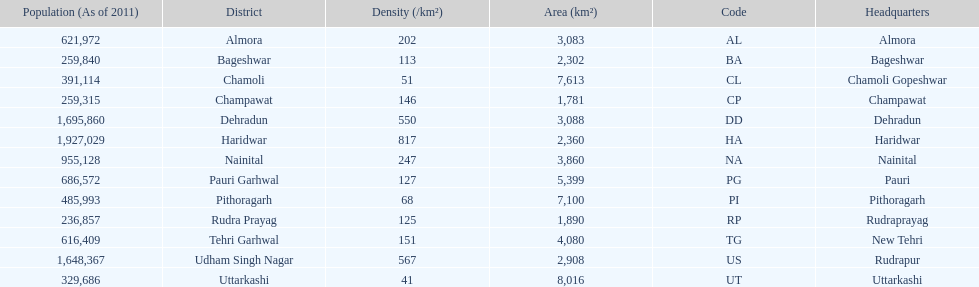How many total districts are there in this area? 13. 